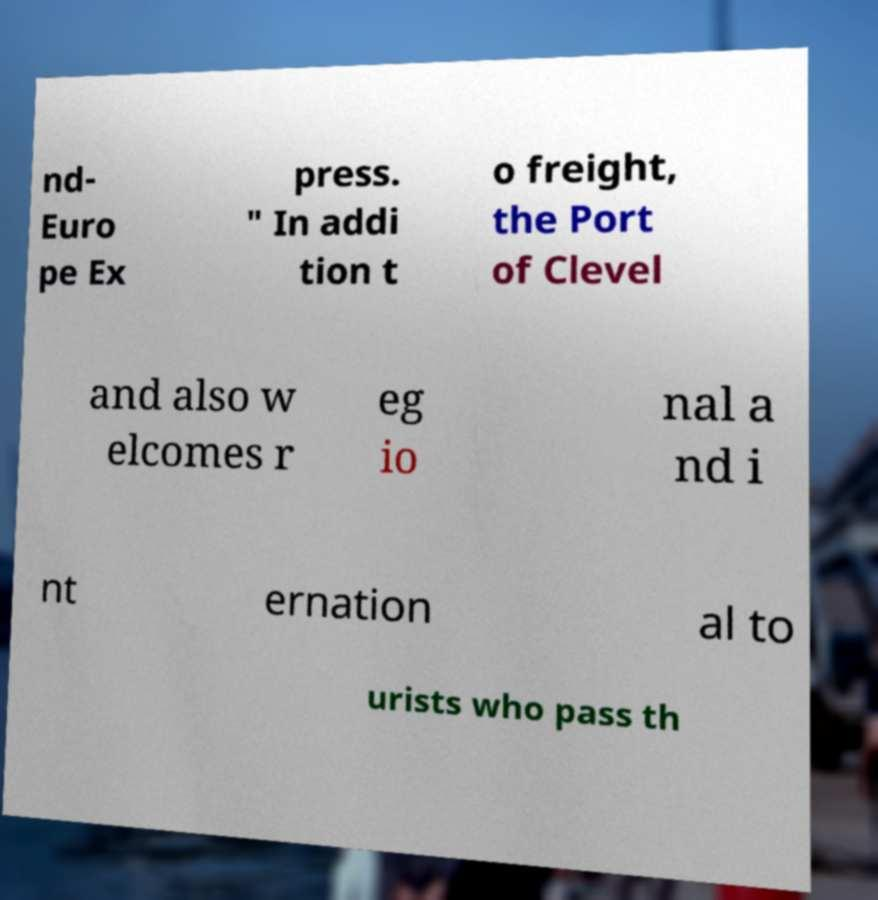Please identify and transcribe the text found in this image. nd- Euro pe Ex press. " In addi tion t o freight, the Port of Clevel and also w elcomes r eg io nal a nd i nt ernation al to urists who pass th 